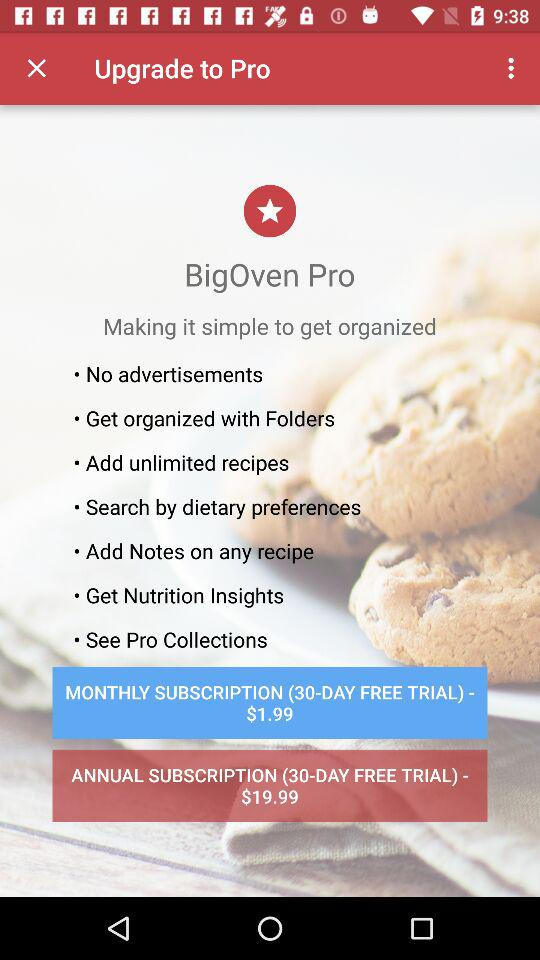What is the benefit of "BigOven Pro"? The benefits are "No advertisements", "Get organized with Folders", "Add unlimited recipes", "Search by dietary preferences", "Add Notes on any recipe", "Get Nutrition Insights" and "See Pro Collections". 